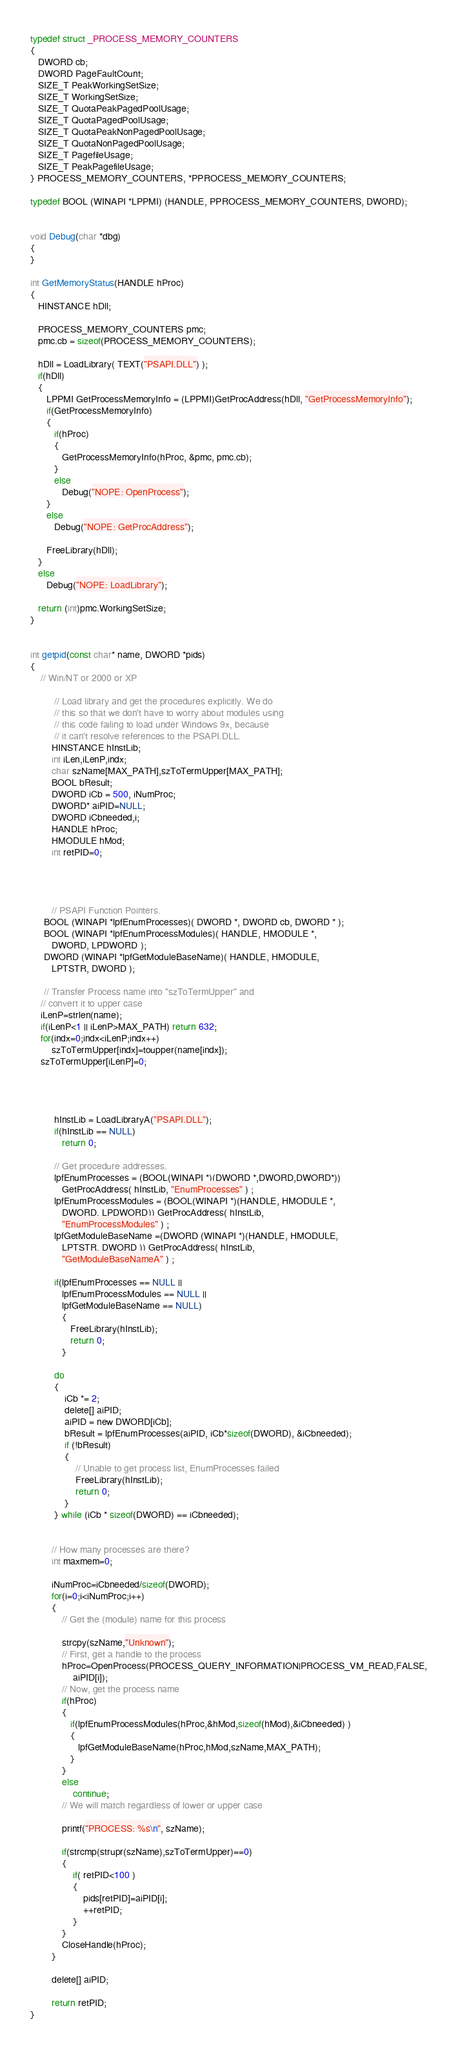<code> <loc_0><loc_0><loc_500><loc_500><_C_>
typedef struct _PROCESS_MEMORY_COUNTERS
{
   DWORD cb;
   DWORD PageFaultCount;
   SIZE_T PeakWorkingSetSize;
   SIZE_T WorkingSetSize;
   SIZE_T QuotaPeakPagedPoolUsage;
   SIZE_T QuotaPagedPoolUsage;
   SIZE_T QuotaPeakNonPagedPoolUsage;
   SIZE_T QuotaNonPagedPoolUsage;
   SIZE_T PagefileUsage;
   SIZE_T PeakPagefileUsage;
} PROCESS_MEMORY_COUNTERS, *PPROCESS_MEMORY_COUNTERS;

typedef BOOL (WINAPI *LPPMI) (HANDLE, PPROCESS_MEMORY_COUNTERS, DWORD);


void Debug(char *dbg)
{
}

int GetMemoryStatus(HANDLE hProc)
{
   HINSTANCE hDll;

   PROCESS_MEMORY_COUNTERS pmc;
   pmc.cb = sizeof(PROCESS_MEMORY_COUNTERS);

   hDll = LoadLibrary( TEXT("PSAPI.DLL") );
   if(hDll)
   {
      LPPMI GetProcessMemoryInfo = (LPPMI)GetProcAddress(hDll, "GetProcessMemoryInfo");
      if(GetProcessMemoryInfo)
      {
         if(hProc)
         {
            GetProcessMemoryInfo(hProc, &pmc, pmc.cb);
         }
         else
            Debug("NOPE: OpenProcess");
      }
      else
         Debug("NOPE: GetProcAddress");

      FreeLibrary(hDll);
   }
   else
      Debug("NOPE: LoadLibrary");

   return (int)pmc.WorkingSetSize;
}


int getpid(const char* name, DWORD *pids)
{
	// Win/NT or 2000 or XP 
 
         // Load library and get the procedures explicitly. We do 
         // this so that we don't have to worry about modules using 
         // this code failing to load under Windows 9x, because 
         // it can't resolve references to the PSAPI.DLL. 
		HINSTANCE hInstLib; 
		int iLen,iLenP,indx; 
		char szName[MAX_PATH],szToTermUpper[MAX_PATH];
		BOOL bResult; 
		DWORD iCb = 500, iNumProc;
		DWORD* aiPID=NULL;
		DWORD iCbneeded,i; 
		HANDLE hProc; 
		HMODULE hMod; 
		int retPID=0;




		// PSAPI Function Pointers. 
     BOOL (WINAPI *lpfEnumProcesses)( DWORD *, DWORD cb, DWORD * ); 
     BOOL (WINAPI *lpfEnumProcessModules)( HANDLE, HMODULE *, 
        DWORD, LPDWORD ); 
     DWORD (WINAPI *lpfGetModuleBaseName)( HANDLE, HMODULE, 
        LPTSTR, DWORD ); 

	 // Transfer Process name into "szToTermUpper" and 
    // convert it to upper case 
    iLenP=strlen(name); 
    if(iLenP<1 || iLenP>MAX_PATH) return 632; 
    for(indx=0;indx<iLenP;indx++) 
        szToTermUpper[indx]=toupper(name[indx]); 
    szToTermUpper[iLenP]=0; 




         hInstLib = LoadLibraryA("PSAPI.DLL"); 
         if(hInstLib == NULL) 
            return 0; 
 
         // Get procedure addresses. 
         lpfEnumProcesses = (BOOL(WINAPI *)(DWORD *,DWORD,DWORD*)) 
            GetProcAddress( hInstLib, "EnumProcesses" ) ; 
         lpfEnumProcessModules = (BOOL(WINAPI *)(HANDLE, HMODULE *, 
            DWORD, LPDWORD)) GetProcAddress( hInstLib, 
            "EnumProcessModules" ) ; 
         lpfGetModuleBaseName =(DWORD (WINAPI *)(HANDLE, HMODULE, 
            LPTSTR, DWORD )) GetProcAddress( hInstLib, 
            "GetModuleBaseNameA" ) ; 
 
         if(lpfEnumProcesses == NULL || 
            lpfEnumProcessModules == NULL || 
            lpfGetModuleBaseName == NULL) 
            { 
               FreeLibrary(hInstLib); 
               return 0; 
            } 
 
		 do
		 {
			 iCb *= 2;
			 delete[] aiPID;
			 aiPID = new DWORD[iCb];
			 bResult = lpfEnumProcesses(aiPID, iCb*sizeof(DWORD), &iCbneeded);
			 if (!bResult)
			 {
				 // Unable to get process list, EnumProcesses failed 
				 FreeLibrary(hInstLib);
				 return 0;
			 }
		 } while (iCb * sizeof(DWORD) == iCbneeded);

 
        // How many processes are there? 
		int maxmem=0;

        iNumProc=iCbneeded/sizeof(DWORD); 
		for(i=0;i<iNumProc;i++) 
        { 
            // Get the (module) name for this process 
 
            strcpy(szName,"Unknown"); 
            // First, get a handle to the process 
            hProc=OpenProcess(PROCESS_QUERY_INFORMATION|PROCESS_VM_READ,FALSE, 
                aiPID[i]); 
            // Now, get the process name 
            if(hProc) 
            { 
               if(lpfEnumProcessModules(hProc,&hMod,sizeof(hMod),&iCbneeded) ) 
               { 
                  lpfGetModuleBaseName(hProc,hMod,szName,MAX_PATH); 
               } 
            } 
			else
				continue;
            // We will match regardless of lower or upper case 

			printf("PROCESS: %s\n", szName);

            if(strcmp(strupr(szName),szToTermUpper)==0)
			{
				if( retPID<100 )
				{
					pids[retPID]=aiPID[i];
					++retPID;
				}
			}
			CloseHandle(hProc); 
		}

		delete[] aiPID;

		return retPID;
}</code> 